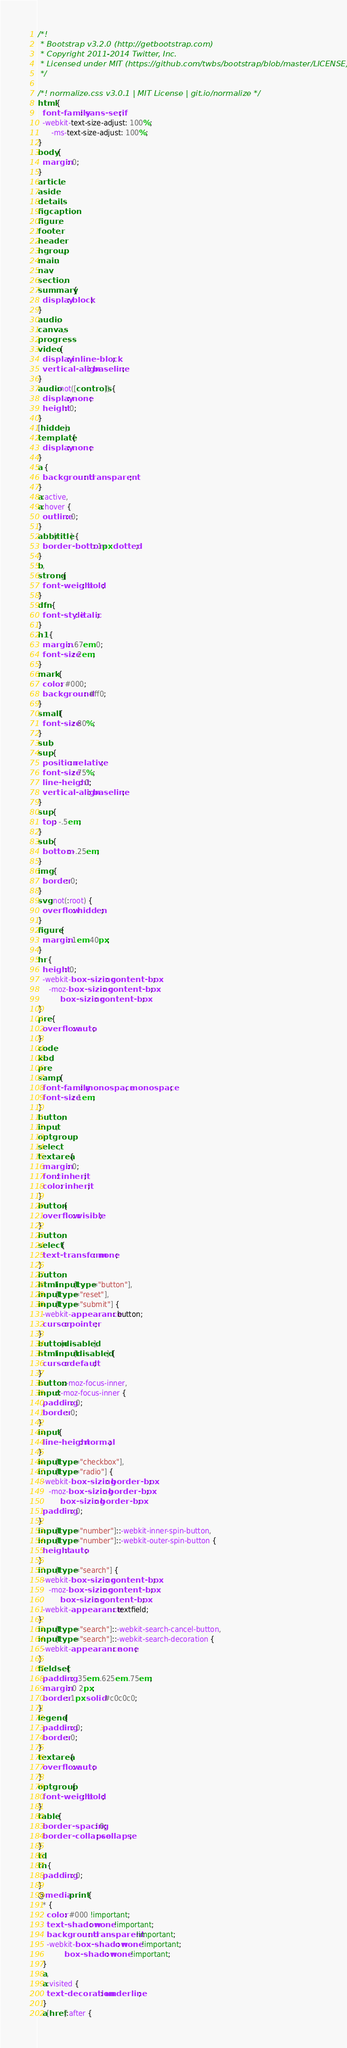Convert code to text. <code><loc_0><loc_0><loc_500><loc_500><_CSS_>/*!
 * Bootstrap v3.2.0 (http://getbootstrap.com)
 * Copyright 2011-2014 Twitter, Inc.
 * Licensed under MIT (https://github.com/twbs/bootstrap/blob/master/LICENSE)
 */

/*! normalize.css v3.0.1 | MIT License | git.io/normalize */
html {
  font-family: sans-serif;
  -webkit-text-size-adjust: 100%;
      -ms-text-size-adjust: 100%;
}
body {
  margin: 0;
}
article,
aside,
details,
figcaption,
figure,
footer,
header,
hgroup,
main,
nav,
section,
summary {
  display: block;
}
audio,
canvas,
progress,
video {
  display: inline-block;
  vertical-align: baseline;
}
audio:not([controls]) {
  display: none;
  height: 0;
}
[hidden],
template {
  display: none;
}
a {
  background: transparent;
}
a:active,
a:hover {
  outline: 0;
}
abbr[title] {
  border-bottom: 1px dotted;
}
b,
strong {
  font-weight: bold;
}
dfn {
  font-style: italic;
}
h1 {
  margin: .67em 0;
  font-size: 2em;
}
mark {
  color: #000;
  background: #ff0;
}
small {
  font-size: 80%;
}
sub,
sup {
  position: relative;
  font-size: 75%;
  line-height: 0;
  vertical-align: baseline;
}
sup {
  top: -.5em;
}
sub {
  bottom: -.25em;
}
img {
  border: 0;
}
svg:not(:root) {
  overflow: hidden;
}
figure {
  margin: 1em 40px;
}
hr {
  height: 0;
  -webkit-box-sizing: content-box;
     -moz-box-sizing: content-box;
          box-sizing: content-box;
}
pre {
  overflow: auto;
}
code,
kbd,
pre,
samp {
  font-family: monospace, monospace;
  font-size: 1em;
}
button,
input,
optgroup,
select,
textarea {
  margin: 0;
  font: inherit;
  color: inherit;
}
button {
  overflow: visible;
}
button,
select {
  text-transform: none;
}
button,
html input[type="button"],
input[type="reset"],
input[type="submit"] {
  -webkit-appearance: button;
  cursor: pointer;
}
button[disabled],
html input[disabled] {
  cursor: default;
}
button::-moz-focus-inner,
input::-moz-focus-inner {
  padding: 0;
  border: 0;
}
input {
  line-height: normal;
}
input[type="checkbox"],
input[type="radio"] {
  -webkit-box-sizing: border-box;
     -moz-box-sizing: border-box;
          box-sizing: border-box;
  padding: 0;
}
input[type="number"]::-webkit-inner-spin-button,
input[type="number"]::-webkit-outer-spin-button {
  height: auto;
}
input[type="search"] {
  -webkit-box-sizing: content-box;
     -moz-box-sizing: content-box;
          box-sizing: content-box;
  -webkit-appearance: textfield;
}
input[type="search"]::-webkit-search-cancel-button,
input[type="search"]::-webkit-search-decoration {
  -webkit-appearance: none;
}
fieldset {
  padding: .35em .625em .75em;
  margin: 0 2px;
  border: 1px solid #c0c0c0;
}
legend {
  padding: 0;
  border: 0;
}
textarea {
  overflow: auto;
}
optgroup {
  font-weight: bold;
}
table {
  border-spacing: 0;
  border-collapse: collapse;
}
td,
th {
  padding: 0;
}
@media print {
  * {
    color: #000 !important;
    text-shadow: none !important;
    background: transparent !important;
    -webkit-box-shadow: none !important;
            box-shadow: none !important;
  }
  a,
  a:visited {
    text-decoration: underline;
  }
  a[href]:after {</code> 